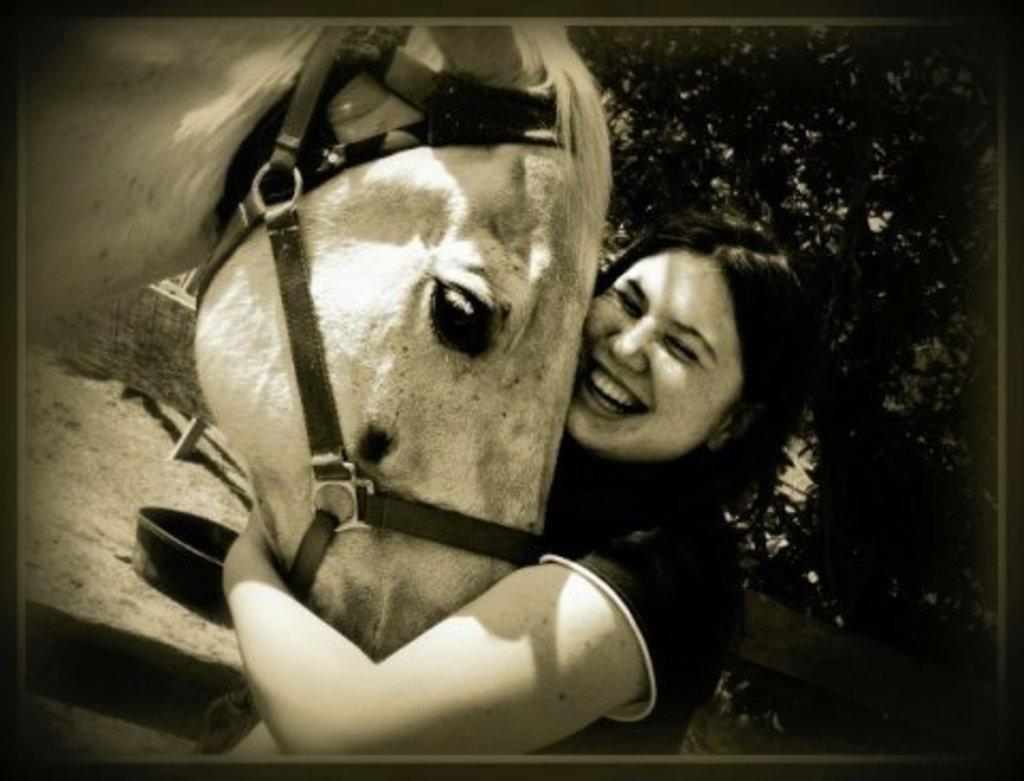What is the color scheme of the image? The image is black and white. Who is present in the image? There is a woman in the image. What is the woman doing in the image? The woman is smiling in the image. What is the woman holding in her hands? The woman is holding an animal in her hands. What can be seen in the background of the image? Trees are visible in the background of the image. What type of beetle can be seen crawling on the woman's shoulder in the image? There is no beetle visible on the woman's shoulder in the image. Can you tell me how many robins are perched on the trees in the background? There are no robins present in the image; only trees can be seen in the background. 